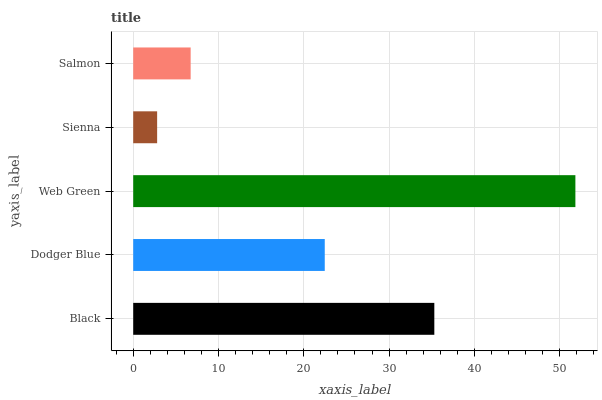Is Sienna the minimum?
Answer yes or no. Yes. Is Web Green the maximum?
Answer yes or no. Yes. Is Dodger Blue the minimum?
Answer yes or no. No. Is Dodger Blue the maximum?
Answer yes or no. No. Is Black greater than Dodger Blue?
Answer yes or no. Yes. Is Dodger Blue less than Black?
Answer yes or no. Yes. Is Dodger Blue greater than Black?
Answer yes or no. No. Is Black less than Dodger Blue?
Answer yes or no. No. Is Dodger Blue the high median?
Answer yes or no. Yes. Is Dodger Blue the low median?
Answer yes or no. Yes. Is Salmon the high median?
Answer yes or no. No. Is Sienna the low median?
Answer yes or no. No. 